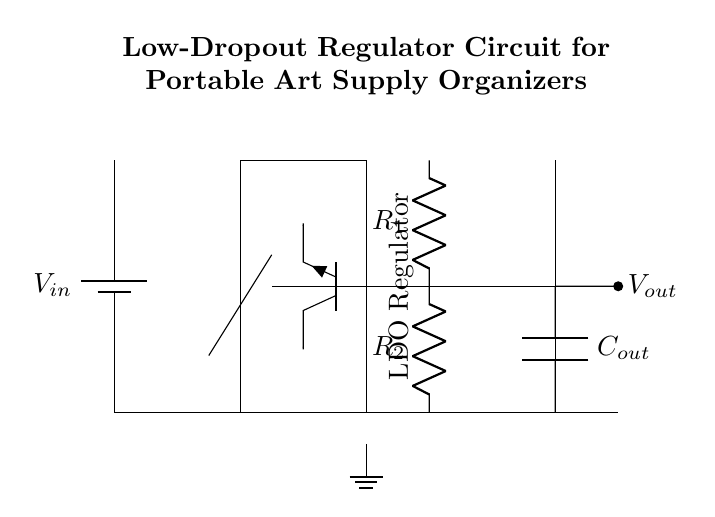What is the input voltage in this circuit? The input voltage is represented by the symbol V_in, typically indicating the source voltage supplying the circuit.
Answer: V_in What is the primary function of the LDO regulator? The LDO regulator regulates the output voltage while allowing for a minimal voltage drop between the input and output, ensuring efficient power management.
Answer: Regulates voltage How many resistors are in the feedback network? There are two resistors labeled R1 and R2 in the feedback network that helps in setting the output voltage.
Answer: Two What type of transistor is used as the pass element? The pass element in the circuit is an NPN transistor, as indicated by the symbol labeled "Tnpn" next to it.
Answer: NPN What component is used to filter the output voltage? The circuit uses a capacitor labeled C_out connected at the output towards ground to filter noise and stabilize the output voltage.
Answer: Capacitor Why is a low-dropout regulator preferred in portable devices? A low-dropout regulator is preferred because it can maintain stable output voltage with very little difference between input and output voltages, extending battery life in portable devices.
Answer: Efficiency 